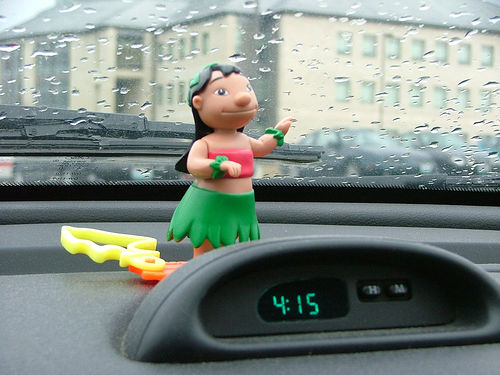Read and extract the text from this image. 4 15 H 